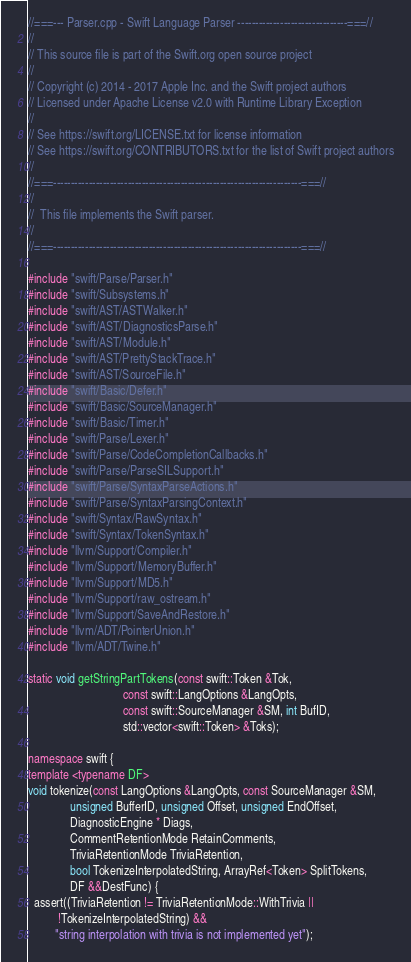<code> <loc_0><loc_0><loc_500><loc_500><_C++_>//===--- Parser.cpp - Swift Language Parser -------------------------------===//
//
// This source file is part of the Swift.org open source project
//
// Copyright (c) 2014 - 2017 Apple Inc. and the Swift project authors
// Licensed under Apache License v2.0 with Runtime Library Exception
//
// See https://swift.org/LICENSE.txt for license information
// See https://swift.org/CONTRIBUTORS.txt for the list of Swift project authors
//
//===----------------------------------------------------------------------===//
//
//  This file implements the Swift parser.
//
//===----------------------------------------------------------------------===//

#include "swift/Parse/Parser.h"
#include "swift/Subsystems.h"
#include "swift/AST/ASTWalker.h"
#include "swift/AST/DiagnosticsParse.h"
#include "swift/AST/Module.h"
#include "swift/AST/PrettyStackTrace.h"
#include "swift/AST/SourceFile.h"
#include "swift/Basic/Defer.h"
#include "swift/Basic/SourceManager.h"
#include "swift/Basic/Timer.h"
#include "swift/Parse/Lexer.h"
#include "swift/Parse/CodeCompletionCallbacks.h"
#include "swift/Parse/ParseSILSupport.h"
#include "swift/Parse/SyntaxParseActions.h"
#include "swift/Parse/SyntaxParsingContext.h"
#include "swift/Syntax/RawSyntax.h"
#include "swift/Syntax/TokenSyntax.h"
#include "llvm/Support/Compiler.h"
#include "llvm/Support/MemoryBuffer.h"
#include "llvm/Support/MD5.h"
#include "llvm/Support/raw_ostream.h"
#include "llvm/Support/SaveAndRestore.h"
#include "llvm/ADT/PointerUnion.h"
#include "llvm/ADT/Twine.h"

static void getStringPartTokens(const swift::Token &Tok,
                                const swift::LangOptions &LangOpts,
                                const swift::SourceManager &SM, int BufID,
                                std::vector<swift::Token> &Toks);

namespace swift {
template <typename DF>
void tokenize(const LangOptions &LangOpts, const SourceManager &SM,
              unsigned BufferID, unsigned Offset, unsigned EndOffset,
              DiagnosticEngine * Diags,
              CommentRetentionMode RetainComments,
              TriviaRetentionMode TriviaRetention,
              bool TokenizeInterpolatedString, ArrayRef<Token> SplitTokens,
              DF &&DestFunc) {
  assert((TriviaRetention != TriviaRetentionMode::WithTrivia ||
          !TokenizeInterpolatedString) &&
         "string interpolation with trivia is not implemented yet");
</code> 